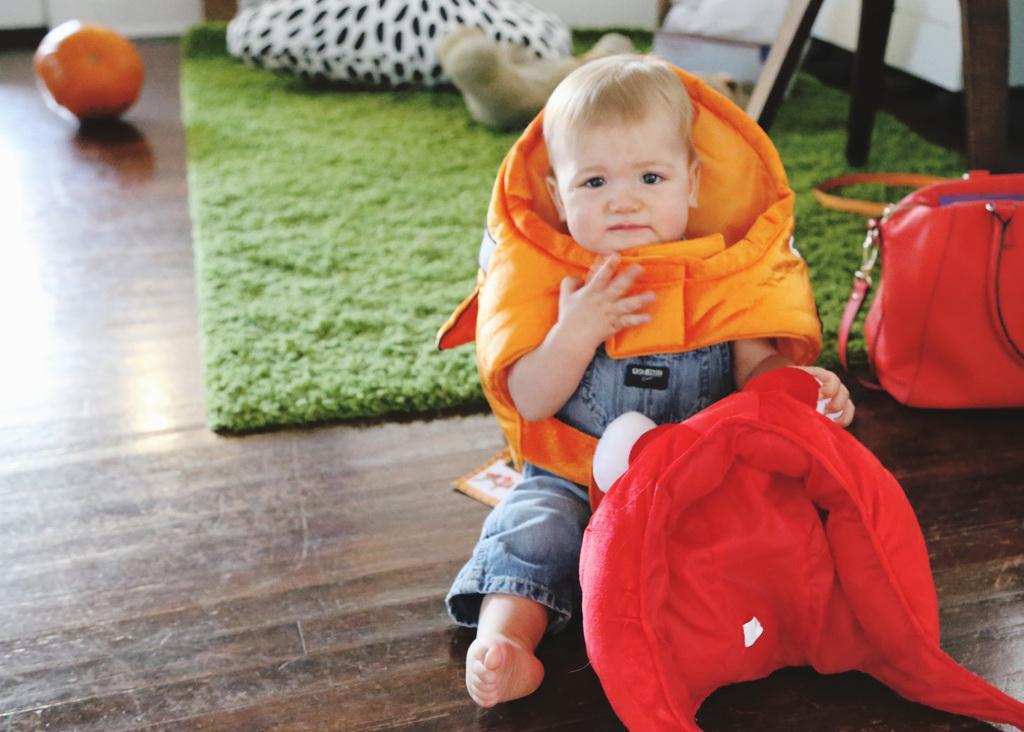In one or two sentences, can you explain what this image depicts? In the center we can see the baby sitting on floor,she is holding doll. On the right side we can see handbag. Coming to back we can see carpet,pillow,chair, some fruit. 